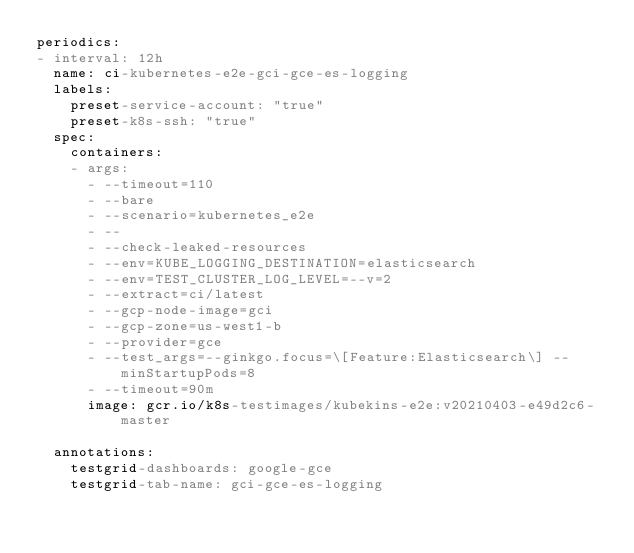<code> <loc_0><loc_0><loc_500><loc_500><_YAML_>periodics:
- interval: 12h
  name: ci-kubernetes-e2e-gci-gce-es-logging
  labels:
    preset-service-account: "true"
    preset-k8s-ssh: "true"
  spec:
    containers:
    - args:
      - --timeout=110
      - --bare
      - --scenario=kubernetes_e2e
      - --
      - --check-leaked-resources
      - --env=KUBE_LOGGING_DESTINATION=elasticsearch
      - --env=TEST_CLUSTER_LOG_LEVEL=--v=2
      - --extract=ci/latest
      - --gcp-node-image=gci
      - --gcp-zone=us-west1-b
      - --provider=gce
      - --test_args=--ginkgo.focus=\[Feature:Elasticsearch\] --minStartupPods=8
      - --timeout=90m
      image: gcr.io/k8s-testimages/kubekins-e2e:v20210403-e49d2c6-master

  annotations:
    testgrid-dashboards: google-gce
    testgrid-tab-name: gci-gce-es-logging
</code> 